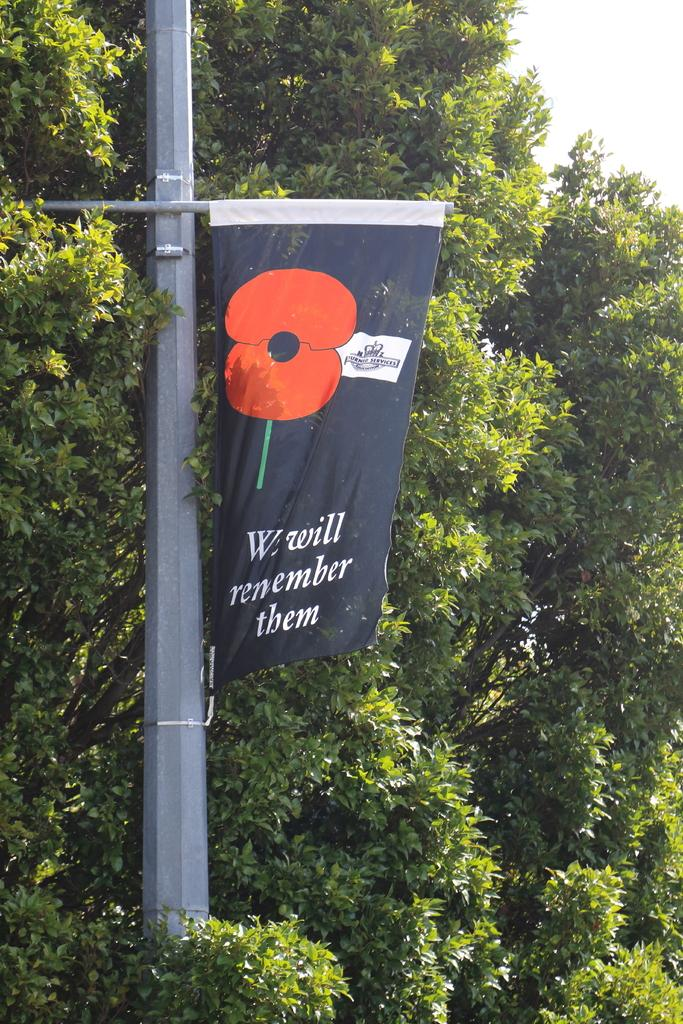What is the main object in the image? There is a pole in the image. What is attached to the pole? The pole has a flex banner. What can be seen in the background of the image? There are trees in the background of the image. What type of garden can be seen in the image? There is no garden present in the image; it features a pole with a flex banner and trees in the background. What wish is granted by the pole in the image? There is no indication of a wish-granting pole in the image; it simply has a flex banner attached. 